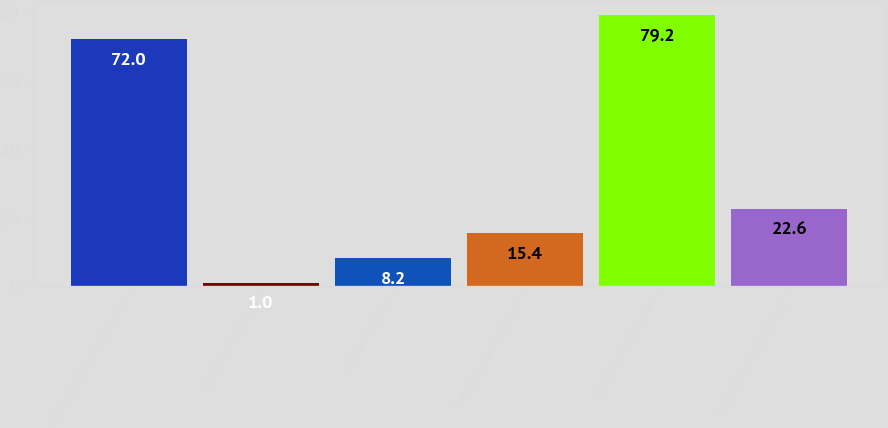Convert chart. <chart><loc_0><loc_0><loc_500><loc_500><bar_chart><fcel>Balance at beginning of year<fcel>Included in earnings<fcel>Included in other<fcel>Purchases issuances and<fcel>Balance at end of year<fcel>Total gains (losses) for the<nl><fcel>72<fcel>1<fcel>8.2<fcel>15.4<fcel>79.2<fcel>22.6<nl></chart> 